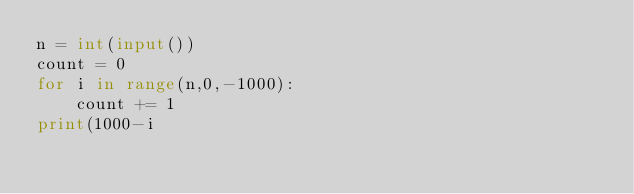<code> <loc_0><loc_0><loc_500><loc_500><_Python_>n = int(input())
count = 0
for i in range(n,0,-1000):
    count += 1
print(1000-i</code> 